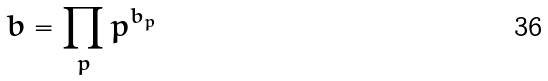Convert formula to latex. <formula><loc_0><loc_0><loc_500><loc_500>b = \prod _ { p } p ^ { b _ { p } }</formula> 